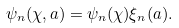<formula> <loc_0><loc_0><loc_500><loc_500>\psi _ { n } ( \chi , a ) = \psi _ { n } ( \chi ) \xi _ { n } ( a ) .</formula> 